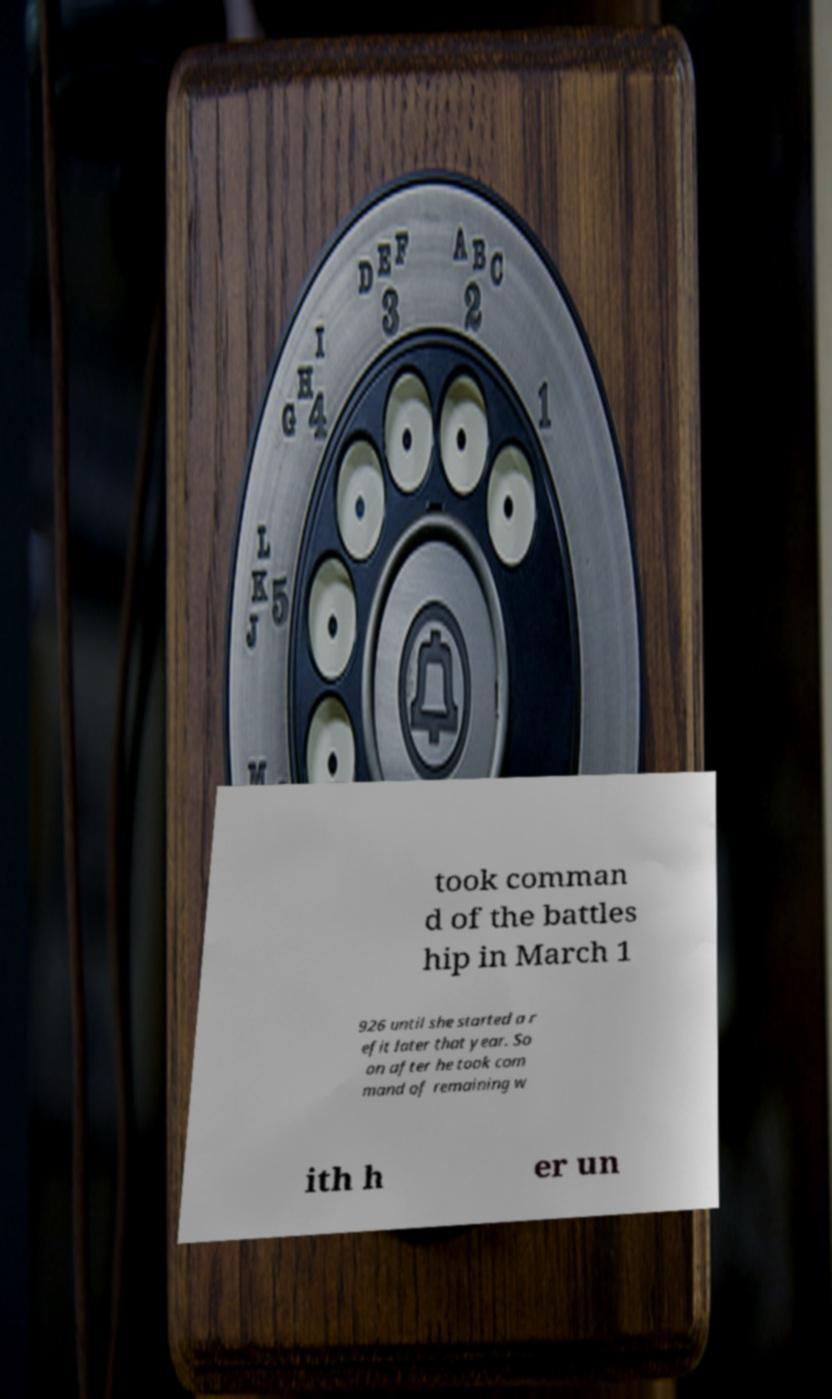There's text embedded in this image that I need extracted. Can you transcribe it verbatim? took comman d of the battles hip in March 1 926 until she started a r efit later that year. So on after he took com mand of remaining w ith h er un 